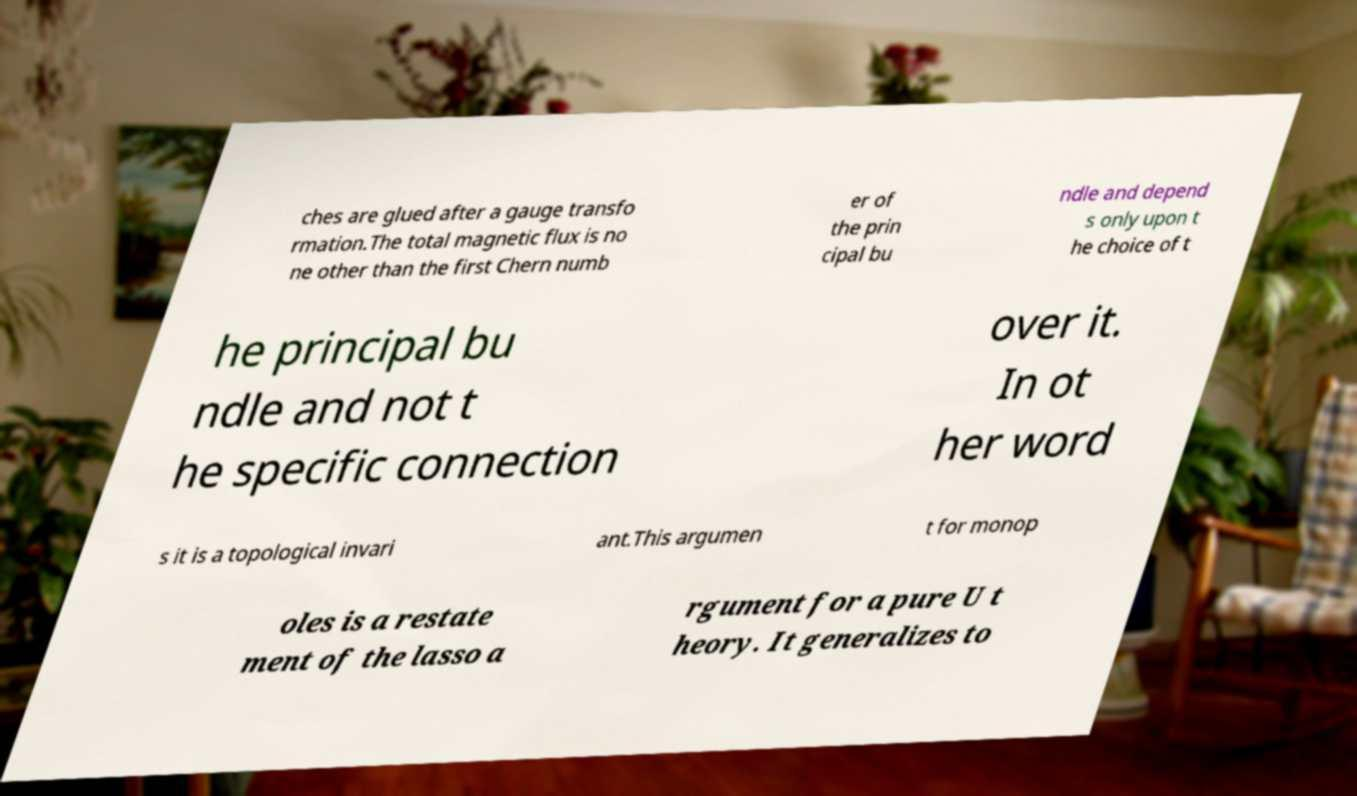What messages or text are displayed in this image? I need them in a readable, typed format. ches are glued after a gauge transfo rmation.The total magnetic flux is no ne other than the first Chern numb er of the prin cipal bu ndle and depend s only upon t he choice of t he principal bu ndle and not t he specific connection over it. In ot her word s it is a topological invari ant.This argumen t for monop oles is a restate ment of the lasso a rgument for a pure U t heory. It generalizes to 